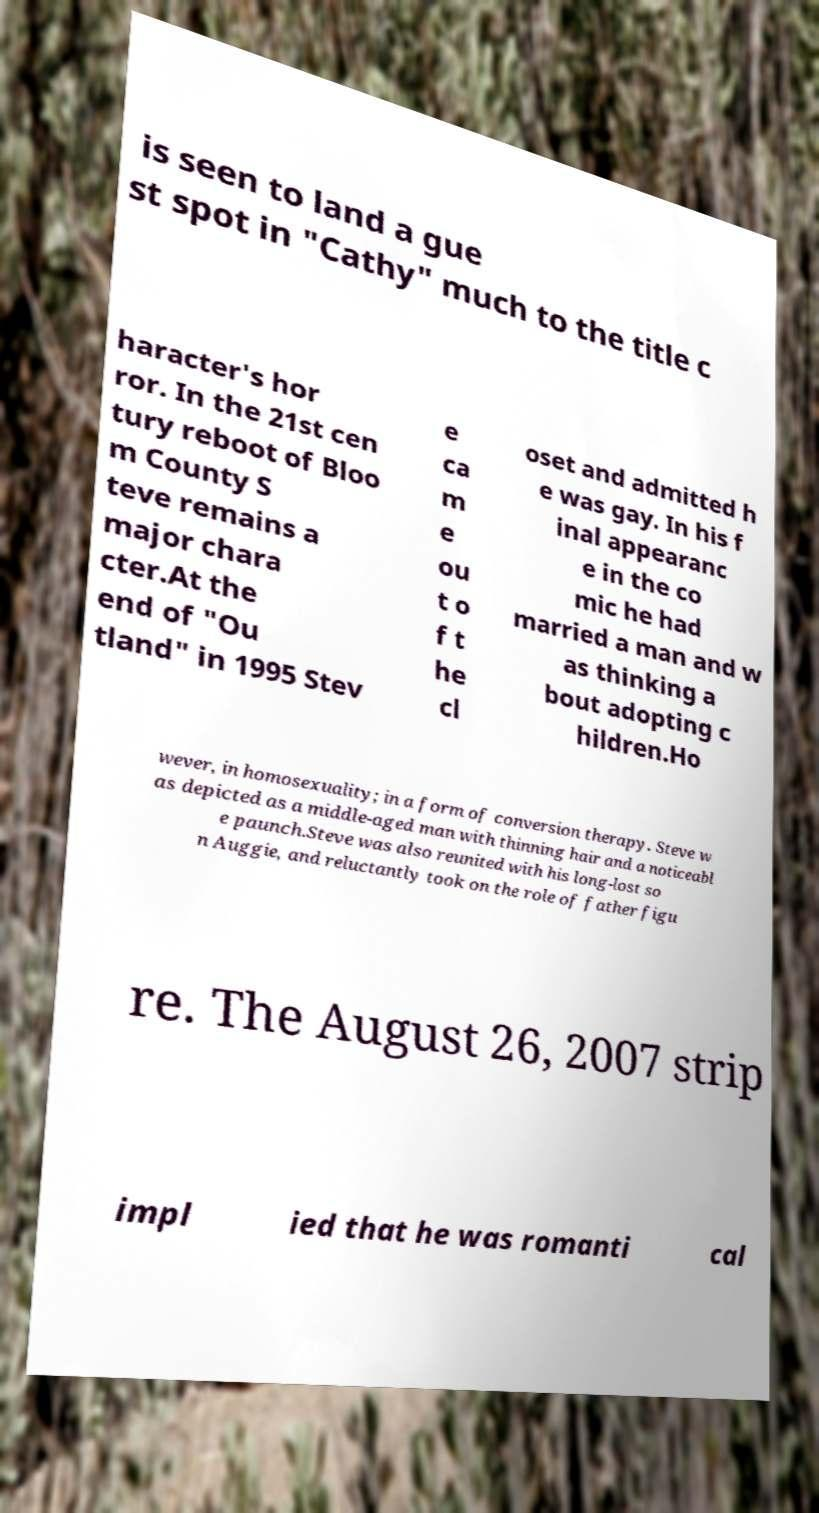Could you assist in decoding the text presented in this image and type it out clearly? is seen to land a gue st spot in "Cathy" much to the title c haracter's hor ror. In the 21st cen tury reboot of Bloo m County S teve remains a major chara cter.At the end of "Ou tland" in 1995 Stev e ca m e ou t o f t he cl oset and admitted h e was gay. In his f inal appearanc e in the co mic he had married a man and w as thinking a bout adopting c hildren.Ho wever, in homosexuality; in a form of conversion therapy. Steve w as depicted as a middle-aged man with thinning hair and a noticeabl e paunch.Steve was also reunited with his long-lost so n Auggie, and reluctantly took on the role of father figu re. The August 26, 2007 strip impl ied that he was romanti cal 